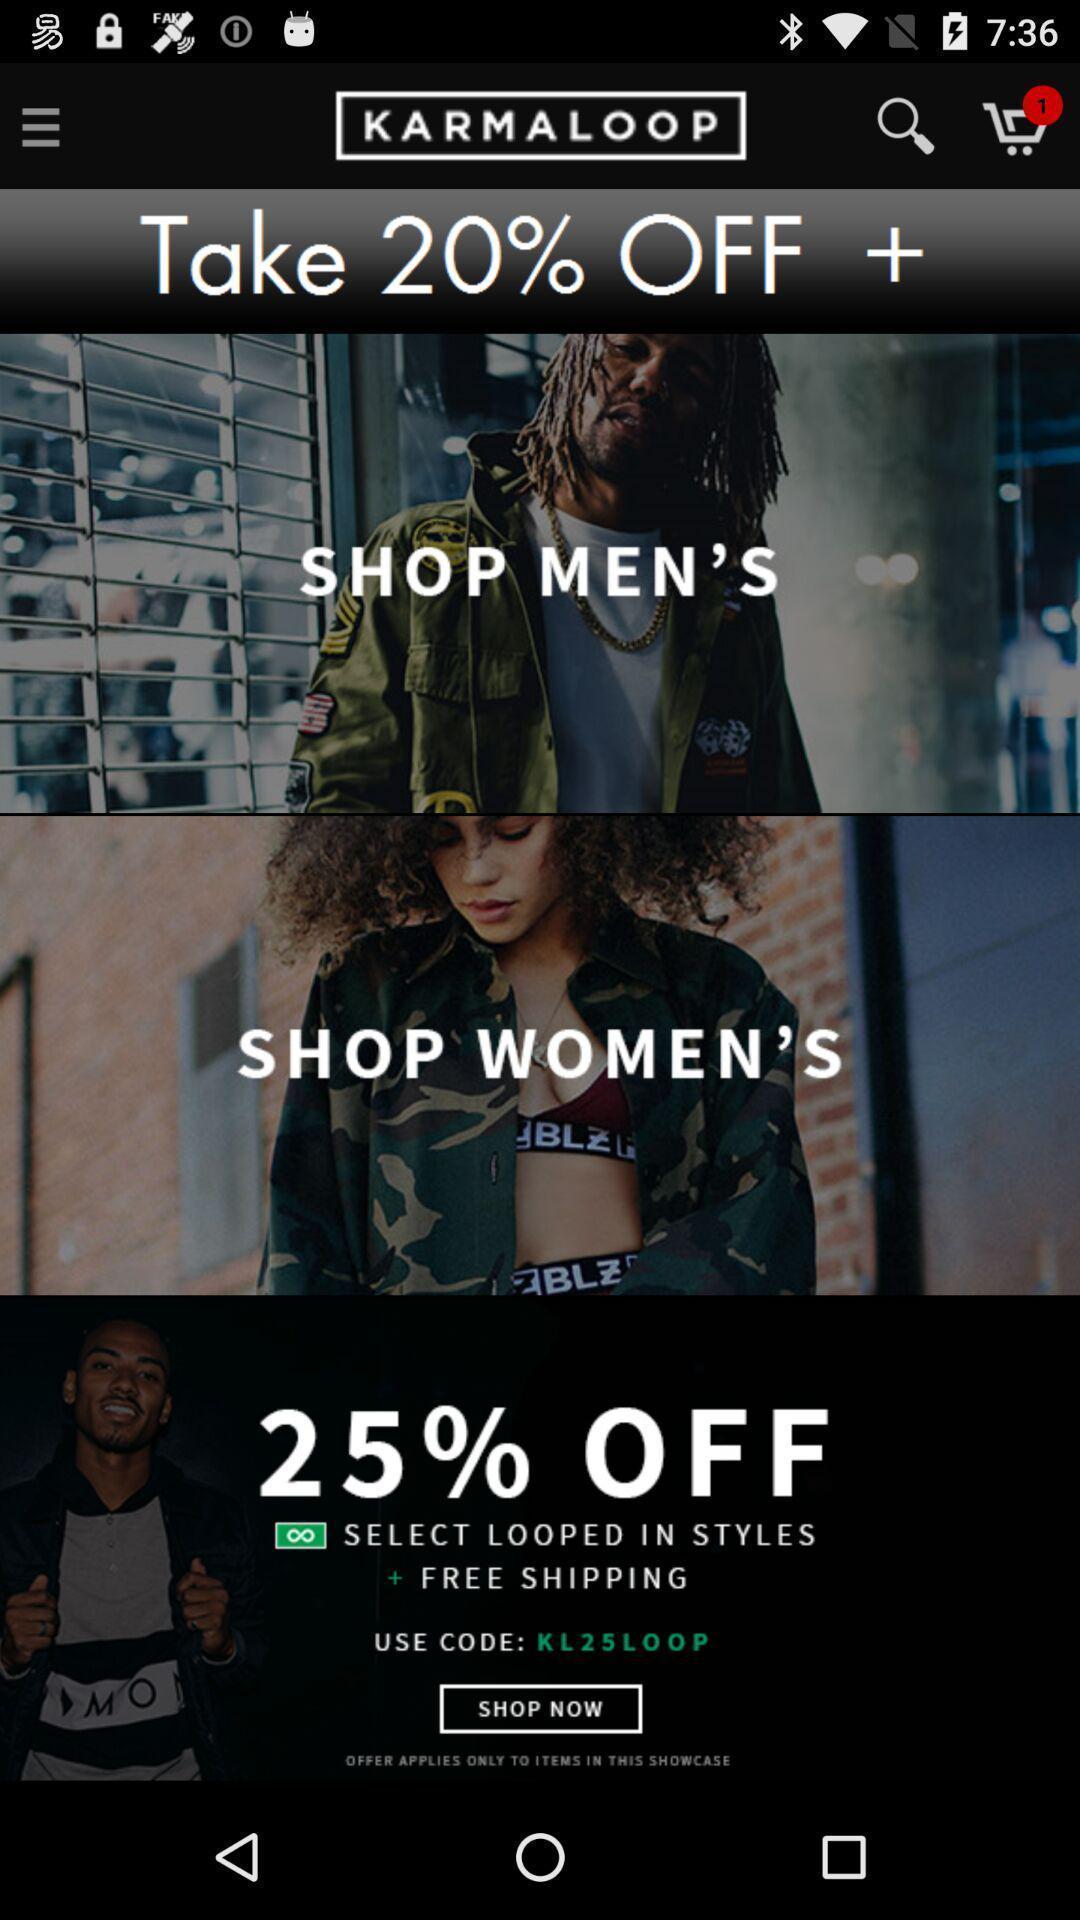Explain the elements present in this screenshot. Page displaying with different offers in shopping application. 